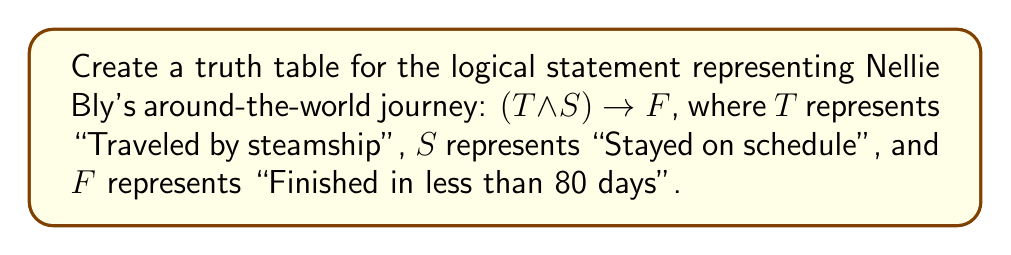Could you help me with this problem? To create a truth table for the given logical statement, we need to follow these steps:

1. Identify the variables: $T$, $S$, and $F$
2. List all possible combinations of truth values for these variables
3. Evaluate the compound statement $(T \land S) \rightarrow F$ for each combination

Step 1: The truth table will have $2^3 = 8$ rows (excluding the header) to cover all possible combinations.

Step 2: Create the table structure and fill in the combinations:

$$
\begin{array}{|c|c|c|c|c|c|}
\hline
T & S & F & T \land S & (T \land S) \rightarrow F \\
\hline
T & T & T & & \\
T & T & F & & \\
T & F & T & & \\
T & F & F & & \\
F & T & T & & \\
F & T & F & & \\
F & F & T & & \\
F & F & F & & \\
\hline
\end{array}
$$

Step 3: Evaluate $T \land S$:

$$
\begin{array}{|c|c|c|c|c|c|}
\hline
T & S & F & T \land S & (T \land S) \rightarrow F \\
\hline
T & T & T & T & \\
T & T & F & T & \\
T & F & T & F & \\
T & F & F & F & \\
F & T & T & F & \\
F & T & F & F & \\
F & F & T & F & \\
F & F & F & F & \\
\hline
\end{array}
$$

Step 4: Evaluate $(T \land S) \rightarrow F$:
Remember, $P \rightarrow Q$ is false only when $P$ is true and $Q$ is false.

$$
\begin{array}{|c|c|c|c|c|c|}
\hline
T & S & F & T \land S & (T \land S) \rightarrow F \\
\hline
T & T & T & T & T \\
T & T & F & T & F \\
T & F & T & F & T \\
T & F & F & F & T \\
F & T & T & F & T \\
F & T & F & F & T \\
F & F & T & F & T \\
F & F & F & F & T \\
\hline
\end{array}
$$

This completes the truth table for Nellie Bly's around-the-world journey logical statement.
Answer: $$
\begin{array}{|c|c|c|c|c|c|}
\hline
T & S & F & T \land S & (T \land S) \rightarrow F \\
\hline
T & T & T & T & T \\
T & T & F & T & F \\
T & F & T & F & T \\
T & F & F & F & T \\
F & T & T & F & T \\
F & T & F & F & T \\
F & F & T & F & T \\
F & F & F & F & T \\
\hline
\end{array}
$$ 